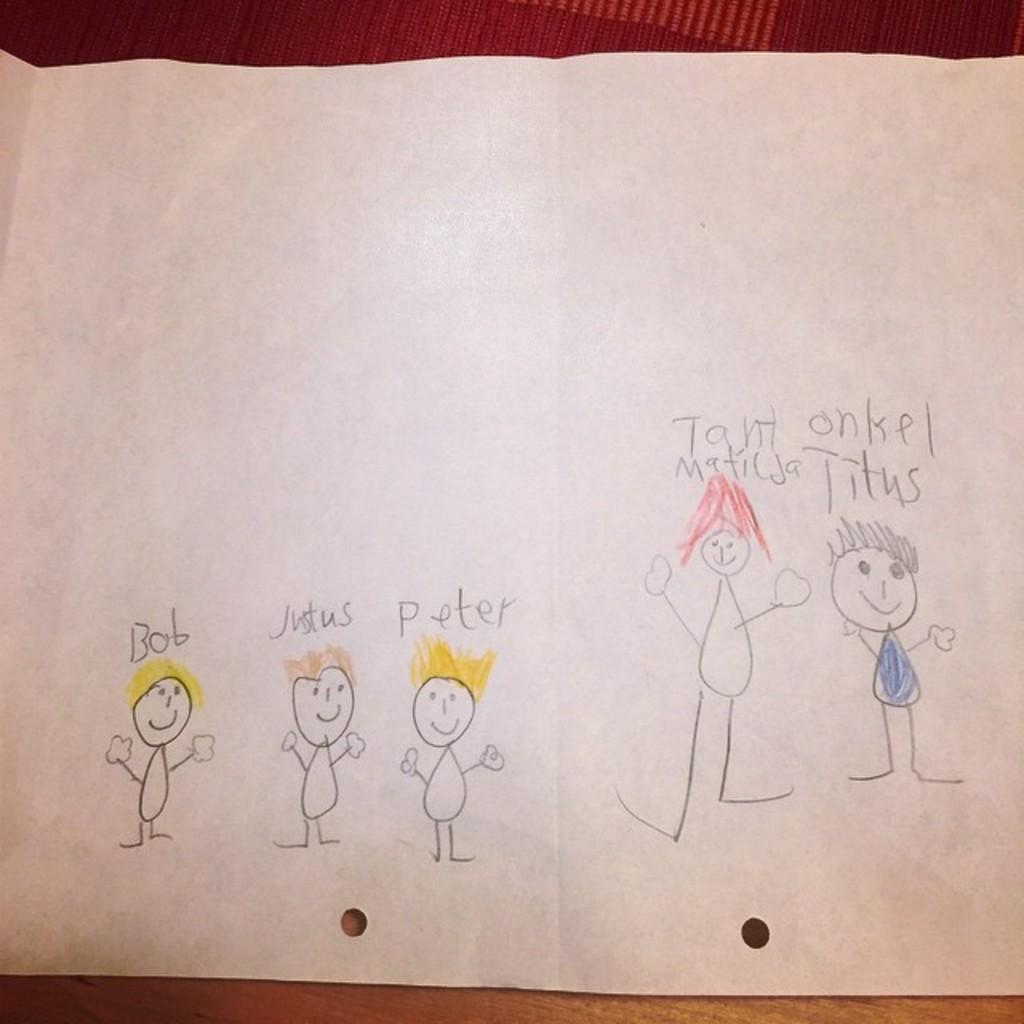What is the main subject in the center of the image? There is a paper in the center of the image. What can be found on the paper? The paper contains a drawing and text. What is visible in the background of the image? There is a table in the background of the image. Where is the deer located in the image? There is no deer present in the image. What type of work is being done on the paper in the image? The image does not provide information about the type of work being done on the paper, as it only shows the presence of a drawing and text. 